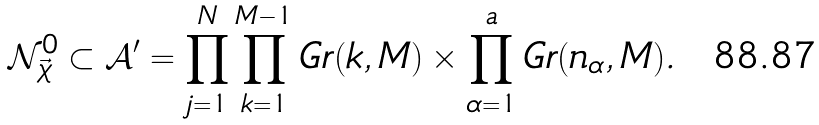<formula> <loc_0><loc_0><loc_500><loc_500>\mathcal { N } _ { \vec { \chi } } ^ { 0 } \subset \mathcal { A } ^ { \prime } = \prod _ { j = 1 } ^ { N } \prod _ { k = 1 } ^ { M - 1 } G r ( k , M ) \times \prod _ { \alpha = 1 } ^ { a } G r ( n _ { \alpha } , M ) .</formula> 